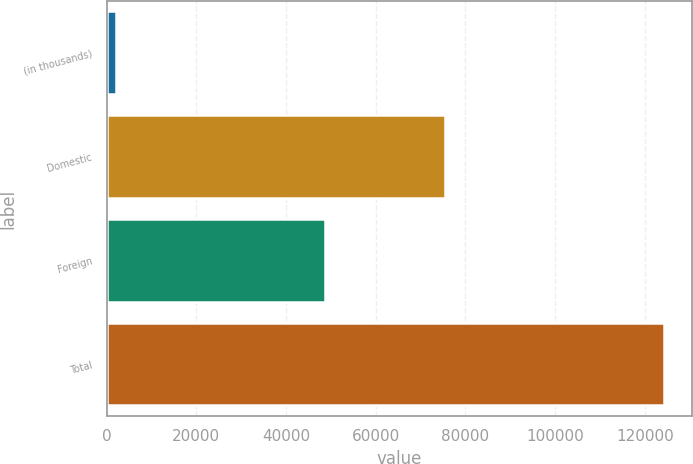<chart> <loc_0><loc_0><loc_500><loc_500><bar_chart><fcel>(in thousands)<fcel>Domestic<fcel>Foreign<fcel>Total<nl><fcel>2007<fcel>75474<fcel>48789<fcel>124263<nl></chart> 